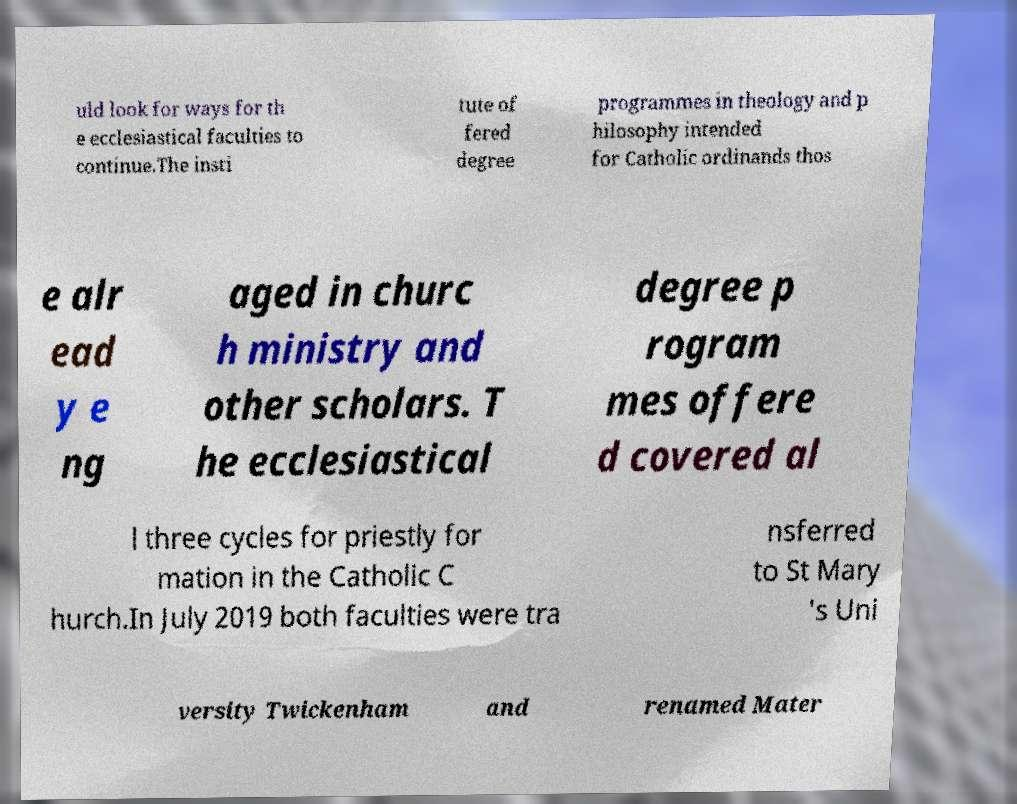Please read and relay the text visible in this image. What does it say? uld look for ways for th e ecclesiastical faculties to continue.The insti tute of fered degree programmes in theology and p hilosophy intended for Catholic ordinands thos e alr ead y e ng aged in churc h ministry and other scholars. T he ecclesiastical degree p rogram mes offere d covered al l three cycles for priestly for mation in the Catholic C hurch.In July 2019 both faculties were tra nsferred to St Mary 's Uni versity Twickenham and renamed Mater 